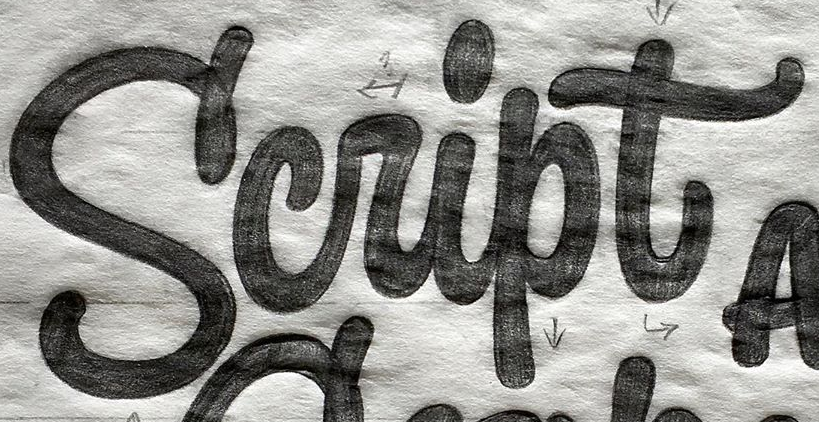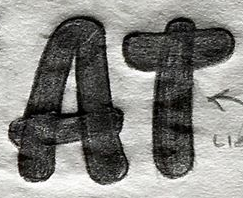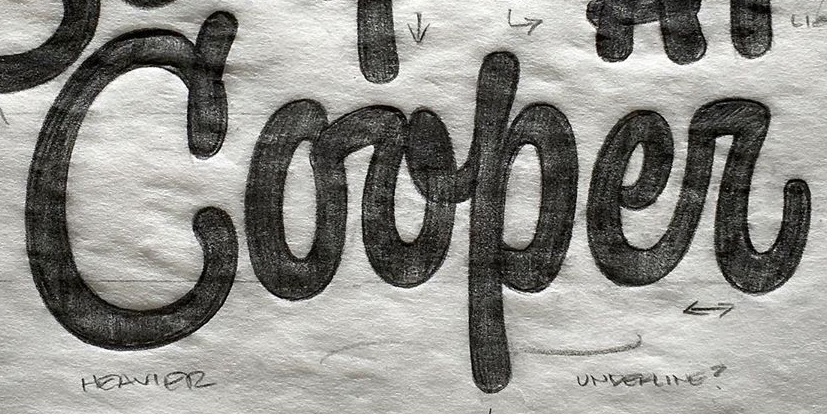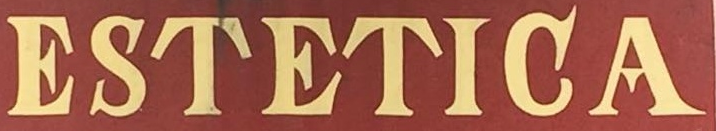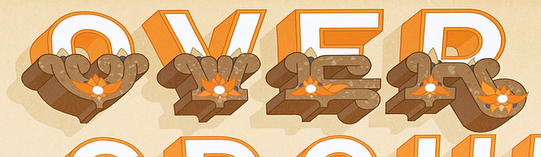Read the text from these images in sequence, separated by a semicolon. Script; AT; Corper; ESTETIGA; OVER 